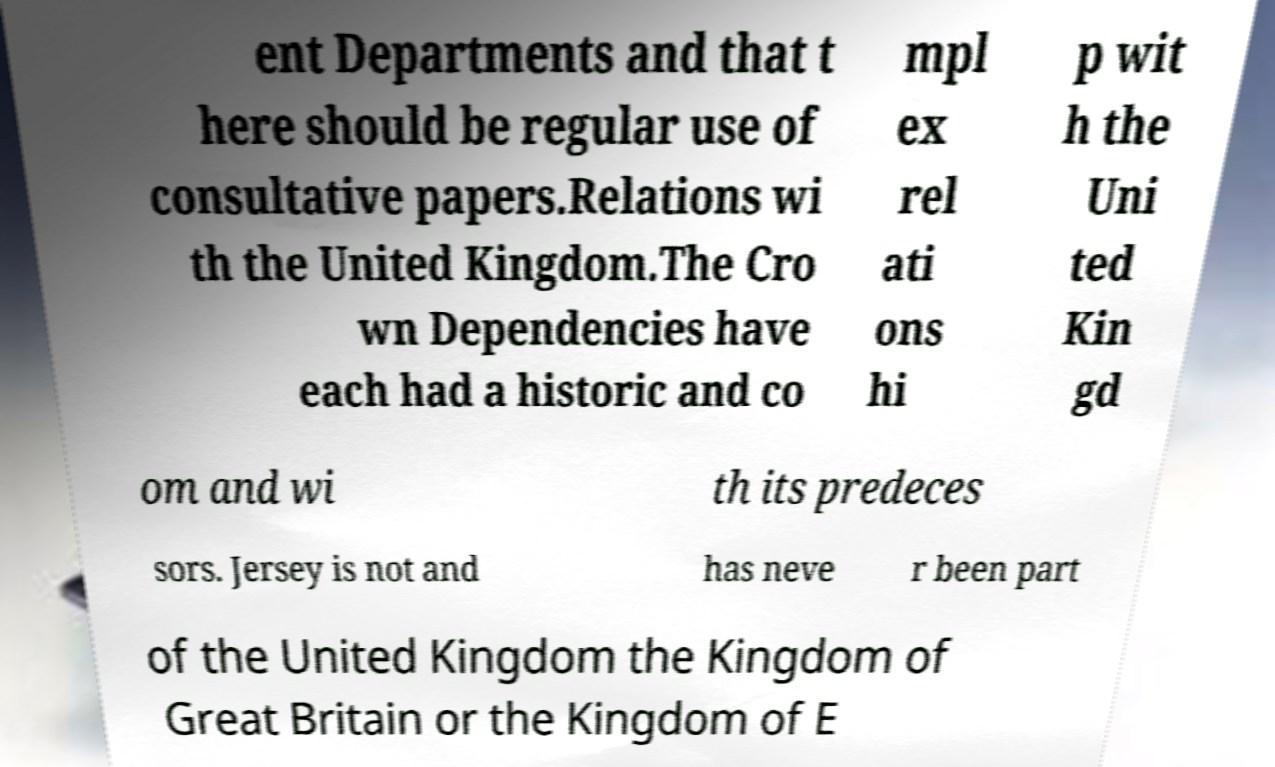Please identify and transcribe the text found in this image. ent Departments and that t here should be regular use of consultative papers.Relations wi th the United Kingdom.The Cro wn Dependencies have each had a historic and co mpl ex rel ati ons hi p wit h the Uni ted Kin gd om and wi th its predeces sors. Jersey is not and has neve r been part of the United Kingdom the Kingdom of Great Britain or the Kingdom of E 